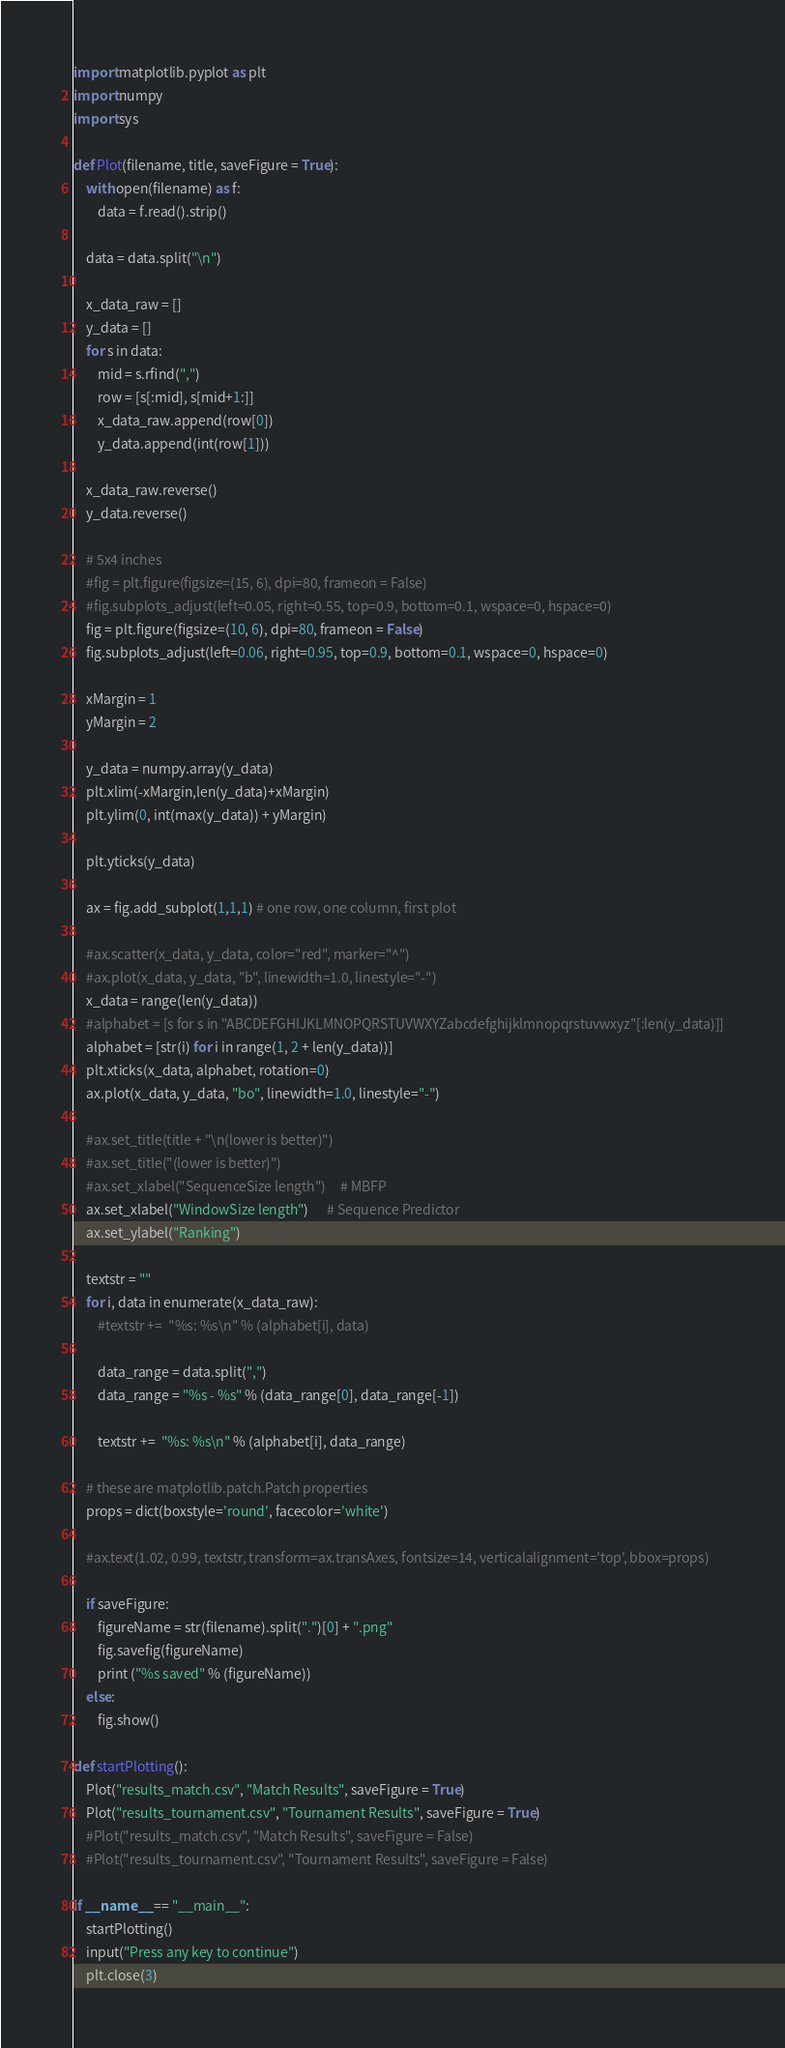<code> <loc_0><loc_0><loc_500><loc_500><_Python_>import matplotlib.pyplot as plt
import numpy
import sys

def Plot(filename, title, saveFigure = True):
    with open(filename) as f:
        data = f.read().strip()

    data = data.split("\n")
        
    x_data_raw = []
    y_data = []
    for s in data:
        mid = s.rfind(",")
        row = [s[:mid], s[mid+1:]]
        x_data_raw.append(row[0])
        y_data.append(int(row[1]))
        
    x_data_raw.reverse()
    y_data.reverse()

    # 5x4 inches
    #fig = plt.figure(figsize=(15, 6), dpi=80, frameon = False)
    #fig.subplots_adjust(left=0.05, right=0.55, top=0.9, bottom=0.1, wspace=0, hspace=0)
    fig = plt.figure(figsize=(10, 6), dpi=80, frameon = False)
    fig.subplots_adjust(left=0.06, right=0.95, top=0.9, bottom=0.1, wspace=0, hspace=0)

    xMargin = 1
    yMargin = 2

    y_data = numpy.array(y_data)    
    plt.xlim(-xMargin,len(y_data)+xMargin)
    plt.ylim(0, int(max(y_data)) + yMargin)
    
    plt.yticks(y_data)
    
    ax = fig.add_subplot(1,1,1) # one row, one column, first plot

    #ax.scatter(x_data, y_data, color="red", marker="^")
    #ax.plot(x_data, y_data, "b", linewidth=1.0, linestyle="-")
    x_data = range(len(y_data))
    #alphabet = [s for s in "ABCDEFGHIJKLMNOPQRSTUVWXYZabcdefghijklmnopqrstuvwxyz"[:len(y_data)]]
    alphabet = [str(i) for i in range(1, 2 + len(y_data))]
    plt.xticks(x_data, alphabet, rotation=0)
    ax.plot(x_data, y_data, "bo", linewidth=1.0, linestyle="-")
    
    #ax.set_title(title + "\n(lower is better)")
    #ax.set_title("(lower is better)")
    #ax.set_xlabel("SequenceSize length")     # MBFP
    ax.set_xlabel("WindowSize length")      # Sequence Predictor
    ax.set_ylabel("Ranking")
    
    textstr = ""
    for i, data in enumerate(x_data_raw):
        #textstr +=  "%s: %s\n" % (alphabet[i], data)
        
        data_range = data.split(",")
        data_range = "%s - %s" % (data_range[0], data_range[-1])
        
        textstr +=  "%s: %s\n" % (alphabet[i], data_range)

    # these are matplotlib.patch.Patch properties
    props = dict(boxstyle='round', facecolor='white')

    #ax.text(1.02, 0.99, textstr, transform=ax.transAxes, fontsize=14, verticalalignment='top', bbox=props)
        
    if saveFigure:
        figureName = str(filename).split(".")[0] + ".png"
        fig.savefig(figureName)
        print ("%s saved" % (figureName))
    else:
        fig.show()

def startPlotting():
    Plot("results_match.csv", "Match Results", saveFigure = True)
    Plot("results_tournament.csv", "Tournament Results", saveFigure = True)    
    #Plot("results_match.csv", "Match Results", saveFigure = False)
    #Plot("results_tournament.csv", "Tournament Results", saveFigure = False)    

if __name__ == "__main__":
    startPlotting()
    input("Press any key to continue")
    plt.close(3)</code> 